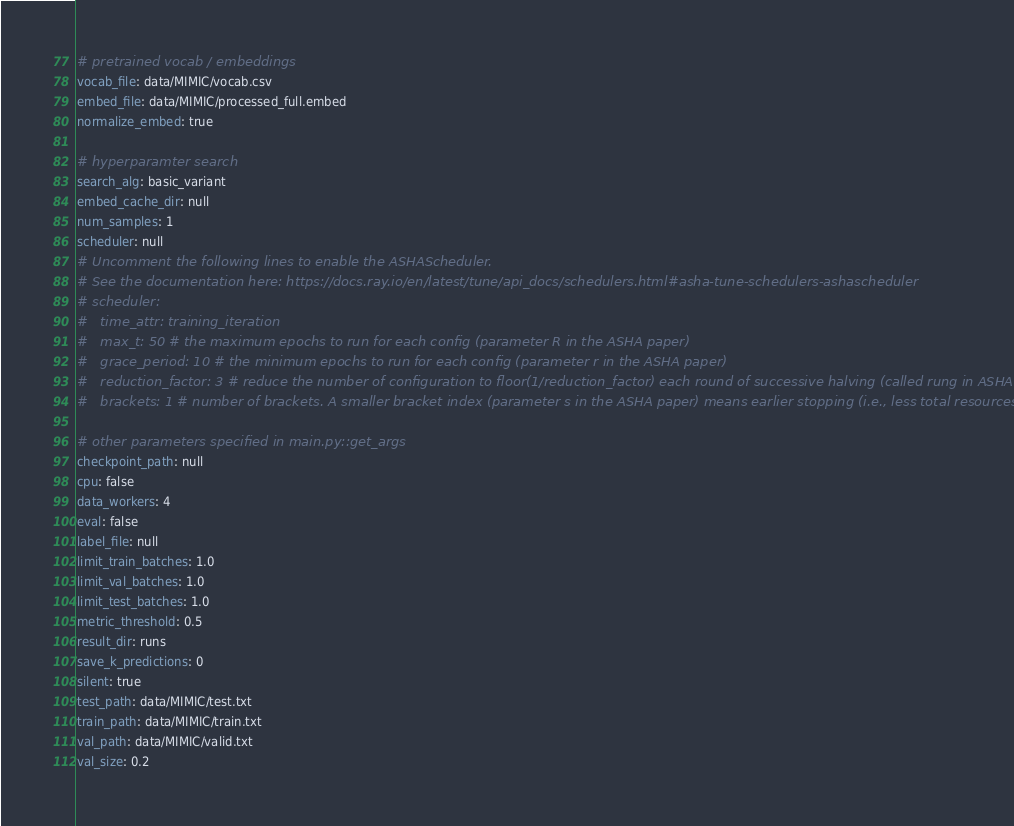<code> <loc_0><loc_0><loc_500><loc_500><_YAML_>
# pretrained vocab / embeddings
vocab_file: data/MIMIC/vocab.csv
embed_file: data/MIMIC/processed_full.embed
normalize_embed: true

# hyperparamter search
search_alg: basic_variant
embed_cache_dir: null
num_samples: 1
scheduler: null
# Uncomment the following lines to enable the ASHAScheduler.
# See the documentation here: https://docs.ray.io/en/latest/tune/api_docs/schedulers.html#asha-tune-schedulers-ashascheduler
# scheduler:
#   time_attr: training_iteration
#   max_t: 50 # the maximum epochs to run for each config (parameter R in the ASHA paper)
#   grace_period: 10 # the minimum epochs to run for each config (parameter r in the ASHA paper)
#   reduction_factor: 3 # reduce the number of configuration to floor(1/reduction_factor) each round of successive halving (called rung in ASHA paper)
#   brackets: 1 # number of brackets. A smaller bracket index (parameter s in the ASHA paper) means earlier stopping (i.e., less total resources used)

# other parameters specified in main.py::get_args
checkpoint_path: null
cpu: false
data_workers: 4
eval: false
label_file: null
limit_train_batches: 1.0
limit_val_batches: 1.0
limit_test_batches: 1.0
metric_threshold: 0.5
result_dir: runs
save_k_predictions: 0
silent: true
test_path: data/MIMIC/test.txt
train_path: data/MIMIC/train.txt
val_path: data/MIMIC/valid.txt
val_size: 0.2
</code> 